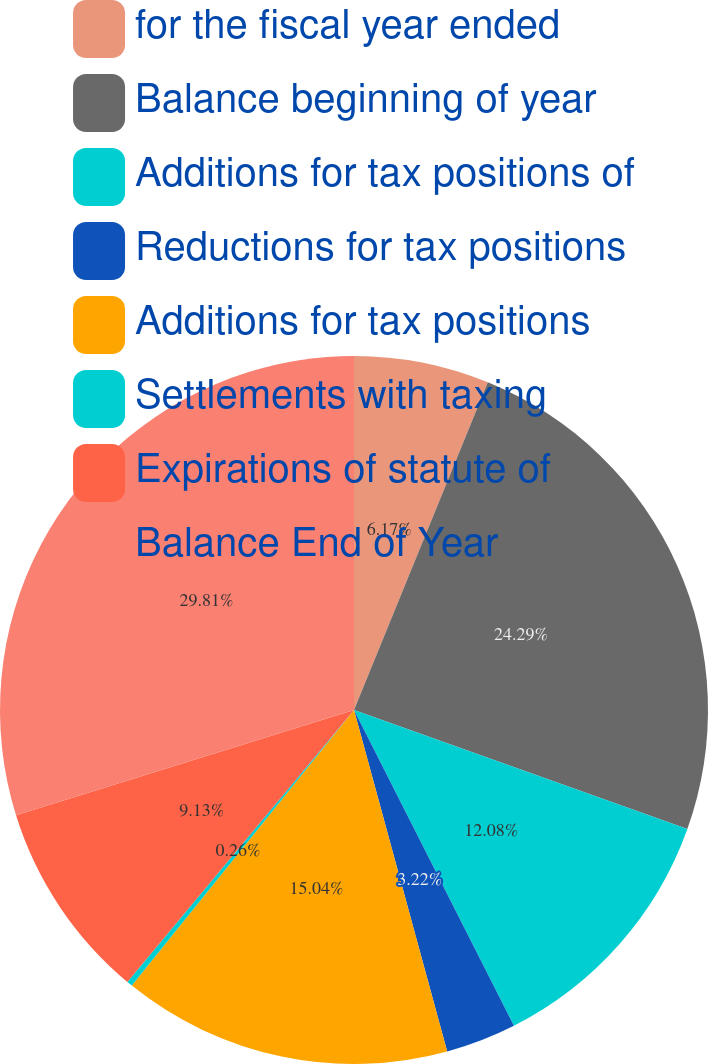Convert chart to OTSL. <chart><loc_0><loc_0><loc_500><loc_500><pie_chart><fcel>for the fiscal year ended<fcel>Balance beginning of year<fcel>Additions for tax positions of<fcel>Reductions for tax positions<fcel>Additions for tax positions<fcel>Settlements with taxing<fcel>Expirations of statute of<fcel>Balance End of Year<nl><fcel>6.17%<fcel>24.29%<fcel>12.08%<fcel>3.22%<fcel>15.04%<fcel>0.26%<fcel>9.13%<fcel>29.81%<nl></chart> 